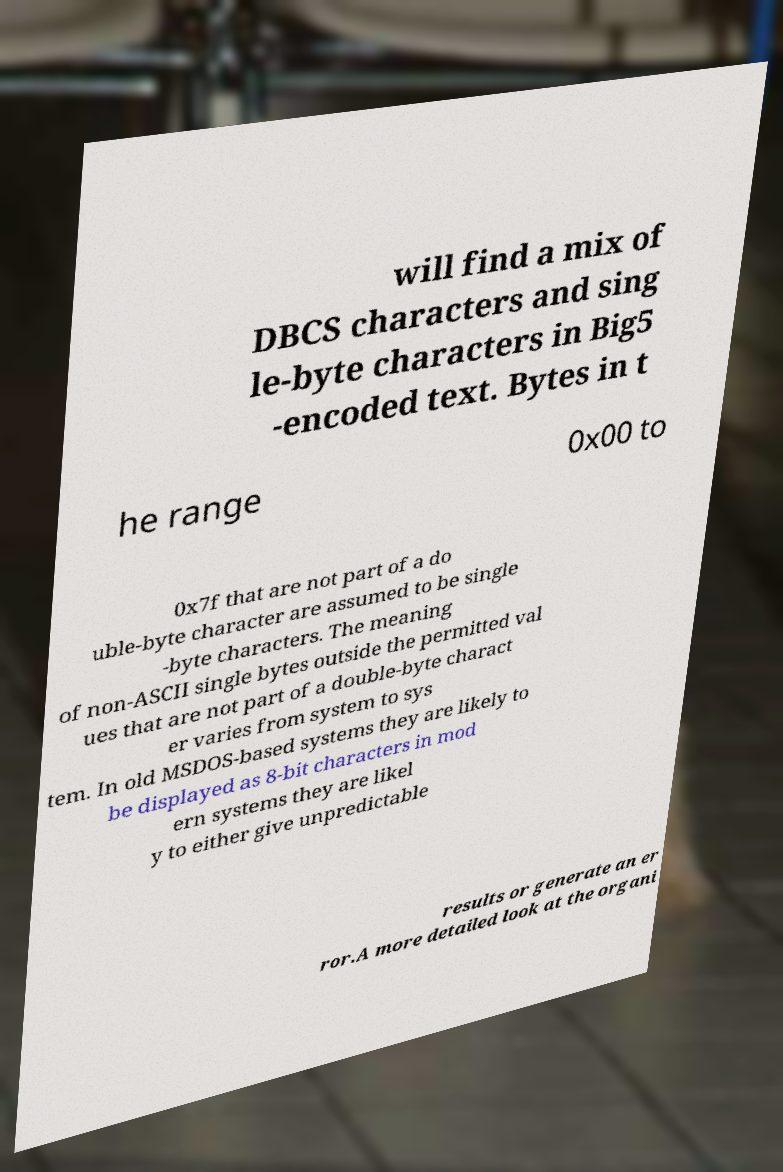Please read and relay the text visible in this image. What does it say? will find a mix of DBCS characters and sing le-byte characters in Big5 -encoded text. Bytes in t he range 0x00 to 0x7f that are not part of a do uble-byte character are assumed to be single -byte characters. The meaning of non-ASCII single bytes outside the permitted val ues that are not part of a double-byte charact er varies from system to sys tem. In old MSDOS-based systems they are likely to be displayed as 8-bit characters in mod ern systems they are likel y to either give unpredictable results or generate an er ror.A more detailed look at the organi 